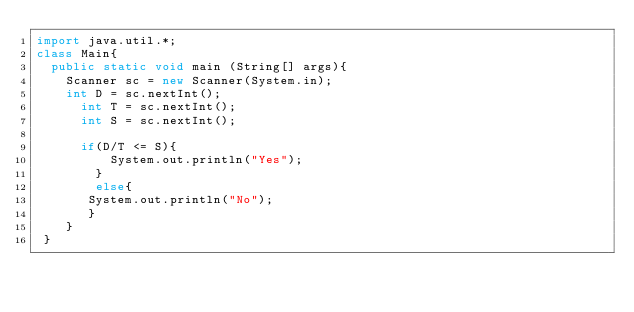<code> <loc_0><loc_0><loc_500><loc_500><_Java_>import java.util.*;
class Main{
	public static void main (String[] args){
		Scanner sc = new Scanner(System.in);
		int D = sc.nextInt();
    	int T = sc.nextInt();
    	int S = sc.nextInt();
    
    	if(D/T <= S){
        	System.out.println("Yes");
        }
        else{
       System.out.println("No");
       }
    }
 }</code> 